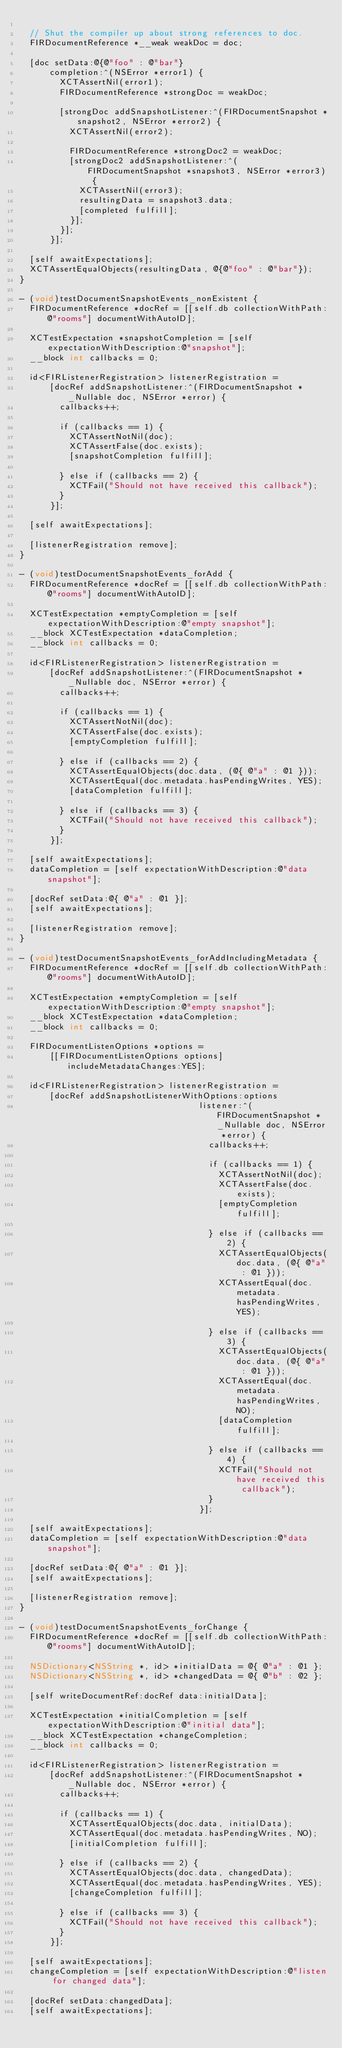<code> <loc_0><loc_0><loc_500><loc_500><_ObjectiveC_>
  // Shut the compiler up about strong references to doc.
  FIRDocumentReference *__weak weakDoc = doc;

  [doc setData:@{@"foo" : @"bar"}
      completion:^(NSError *error1) {
        XCTAssertNil(error1);
        FIRDocumentReference *strongDoc = weakDoc;

        [strongDoc addSnapshotListener:^(FIRDocumentSnapshot *snapshot2, NSError *error2) {
          XCTAssertNil(error2);

          FIRDocumentReference *strongDoc2 = weakDoc;
          [strongDoc2 addSnapshotListener:^(FIRDocumentSnapshot *snapshot3, NSError *error3) {
            XCTAssertNil(error3);
            resultingData = snapshot3.data;
            [completed fulfill];
          }];
        }];
      }];

  [self awaitExpectations];
  XCTAssertEqualObjects(resultingData, @{@"foo" : @"bar"});
}

- (void)testDocumentSnapshotEvents_nonExistent {
  FIRDocumentReference *docRef = [[self.db collectionWithPath:@"rooms"] documentWithAutoID];

  XCTestExpectation *snapshotCompletion = [self expectationWithDescription:@"snapshot"];
  __block int callbacks = 0;

  id<FIRListenerRegistration> listenerRegistration =
      [docRef addSnapshotListener:^(FIRDocumentSnapshot *_Nullable doc, NSError *error) {
        callbacks++;

        if (callbacks == 1) {
          XCTAssertNotNil(doc);
          XCTAssertFalse(doc.exists);
          [snapshotCompletion fulfill];

        } else if (callbacks == 2) {
          XCTFail("Should not have received this callback");
        }
      }];

  [self awaitExpectations];

  [listenerRegistration remove];
}

- (void)testDocumentSnapshotEvents_forAdd {
  FIRDocumentReference *docRef = [[self.db collectionWithPath:@"rooms"] documentWithAutoID];

  XCTestExpectation *emptyCompletion = [self expectationWithDescription:@"empty snapshot"];
  __block XCTestExpectation *dataCompletion;
  __block int callbacks = 0;

  id<FIRListenerRegistration> listenerRegistration =
      [docRef addSnapshotListener:^(FIRDocumentSnapshot *_Nullable doc, NSError *error) {
        callbacks++;

        if (callbacks == 1) {
          XCTAssertNotNil(doc);
          XCTAssertFalse(doc.exists);
          [emptyCompletion fulfill];

        } else if (callbacks == 2) {
          XCTAssertEqualObjects(doc.data, (@{ @"a" : @1 }));
          XCTAssertEqual(doc.metadata.hasPendingWrites, YES);
          [dataCompletion fulfill];

        } else if (callbacks == 3) {
          XCTFail("Should not have received this callback");
        }
      }];

  [self awaitExpectations];
  dataCompletion = [self expectationWithDescription:@"data snapshot"];

  [docRef setData:@{ @"a" : @1 }];
  [self awaitExpectations];

  [listenerRegistration remove];
}

- (void)testDocumentSnapshotEvents_forAddIncludingMetadata {
  FIRDocumentReference *docRef = [[self.db collectionWithPath:@"rooms"] documentWithAutoID];

  XCTestExpectation *emptyCompletion = [self expectationWithDescription:@"empty snapshot"];
  __block XCTestExpectation *dataCompletion;
  __block int callbacks = 0;

  FIRDocumentListenOptions *options =
      [[FIRDocumentListenOptions options] includeMetadataChanges:YES];

  id<FIRListenerRegistration> listenerRegistration =
      [docRef addSnapshotListenerWithOptions:options
                                    listener:^(FIRDocumentSnapshot *_Nullable doc, NSError *error) {
                                      callbacks++;

                                      if (callbacks == 1) {
                                        XCTAssertNotNil(doc);
                                        XCTAssertFalse(doc.exists);
                                        [emptyCompletion fulfill];

                                      } else if (callbacks == 2) {
                                        XCTAssertEqualObjects(doc.data, (@{ @"a" : @1 }));
                                        XCTAssertEqual(doc.metadata.hasPendingWrites, YES);

                                      } else if (callbacks == 3) {
                                        XCTAssertEqualObjects(doc.data, (@{ @"a" : @1 }));
                                        XCTAssertEqual(doc.metadata.hasPendingWrites, NO);
                                        [dataCompletion fulfill];

                                      } else if (callbacks == 4) {
                                        XCTFail("Should not have received this callback");
                                      }
                                    }];

  [self awaitExpectations];
  dataCompletion = [self expectationWithDescription:@"data snapshot"];

  [docRef setData:@{ @"a" : @1 }];
  [self awaitExpectations];

  [listenerRegistration remove];
}

- (void)testDocumentSnapshotEvents_forChange {
  FIRDocumentReference *docRef = [[self.db collectionWithPath:@"rooms"] documentWithAutoID];

  NSDictionary<NSString *, id> *initialData = @{ @"a" : @1 };
  NSDictionary<NSString *, id> *changedData = @{ @"b" : @2 };

  [self writeDocumentRef:docRef data:initialData];

  XCTestExpectation *initialCompletion = [self expectationWithDescription:@"initial data"];
  __block XCTestExpectation *changeCompletion;
  __block int callbacks = 0;

  id<FIRListenerRegistration> listenerRegistration =
      [docRef addSnapshotListener:^(FIRDocumentSnapshot *_Nullable doc, NSError *error) {
        callbacks++;

        if (callbacks == 1) {
          XCTAssertEqualObjects(doc.data, initialData);
          XCTAssertEqual(doc.metadata.hasPendingWrites, NO);
          [initialCompletion fulfill];

        } else if (callbacks == 2) {
          XCTAssertEqualObjects(doc.data, changedData);
          XCTAssertEqual(doc.metadata.hasPendingWrites, YES);
          [changeCompletion fulfill];

        } else if (callbacks == 3) {
          XCTFail("Should not have received this callback");
        }
      }];

  [self awaitExpectations];
  changeCompletion = [self expectationWithDescription:@"listen for changed data"];

  [docRef setData:changedData];
  [self awaitExpectations];
</code> 